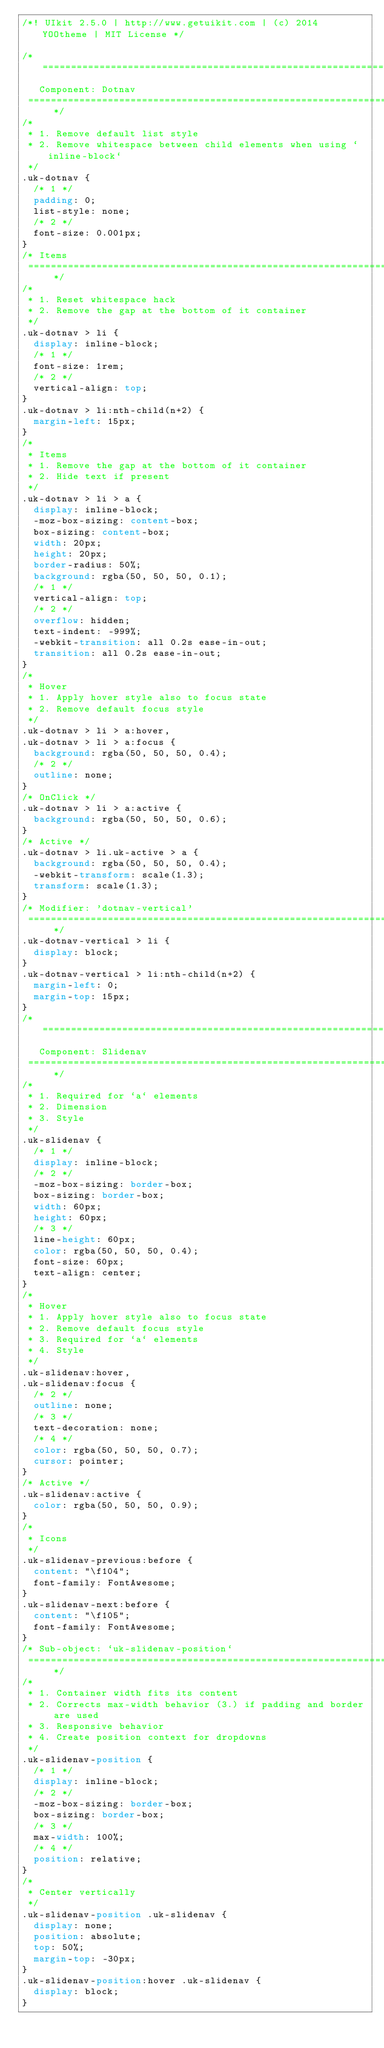<code> <loc_0><loc_0><loc_500><loc_500><_CSS_>/*! UIkit 2.5.0 | http://www.getuikit.com | (c) 2014 YOOtheme | MIT License */

/* ========================================================================
   Component: Dotnav
 ========================================================================== */
/*
 * 1. Remove default list style
 * 2. Remove whitespace between child elements when using `inline-block`
 */
.uk-dotnav {
  /* 1 */
  padding: 0;
  list-style: none;
  /* 2 */
  font-size: 0.001px;
}
/* Items
 ========================================================================== */
/*
 * 1. Reset whitespace hack
 * 2. Remove the gap at the bottom of it container
 */
.uk-dotnav > li {
  display: inline-block;
  /* 1 */
  font-size: 1rem;
  /* 2 */
  vertical-align: top;
}
.uk-dotnav > li:nth-child(n+2) {
  margin-left: 15px;
}
/*
 * Items
 * 1. Remove the gap at the bottom of it container
 * 2. Hide text if present
 */
.uk-dotnav > li > a {
  display: inline-block;
  -moz-box-sizing: content-box;
  box-sizing: content-box;
  width: 20px;
  height: 20px;
  border-radius: 50%;
  background: rgba(50, 50, 50, 0.1);
  /* 1 */
  vertical-align: top;
  /* 2 */
  overflow: hidden;
  text-indent: -999%;
  -webkit-transition: all 0.2s ease-in-out;
  transition: all 0.2s ease-in-out;
}
/*
 * Hover
 * 1. Apply hover style also to focus state
 * 2. Remove default focus style
 */
.uk-dotnav > li > a:hover,
.uk-dotnav > li > a:focus {
  background: rgba(50, 50, 50, 0.4);
  /* 2 */
  outline: none;
}
/* OnClick */
.uk-dotnav > li > a:active {
  background: rgba(50, 50, 50, 0.6);
}
/* Active */
.uk-dotnav > li.uk-active > a {
  background: rgba(50, 50, 50, 0.4);
  -webkit-transform: scale(1.3);
  transform: scale(1.3);
}
/* Modifier: 'dotnav-vertical'
 ========================================================================== */
.uk-dotnav-vertical > li {
  display: block;
}
.uk-dotnav-vertical > li:nth-child(n+2) {
  margin-left: 0;
  margin-top: 15px;
}
/* ========================================================================
   Component: Slidenav
 ========================================================================== */
/*
 * 1. Required for `a` elements
 * 2. Dimension
 * 3. Style
 */
.uk-slidenav {
  /* 1 */
  display: inline-block;
  /* 2 */
  -moz-box-sizing: border-box;
  box-sizing: border-box;
  width: 60px;
  height: 60px;
  /* 3 */
  line-height: 60px;
  color: rgba(50, 50, 50, 0.4);
  font-size: 60px;
  text-align: center;
}
/*
 * Hover
 * 1. Apply hover style also to focus state
 * 2. Remove default focus style
 * 3. Required for `a` elements
 * 4. Style
 */
.uk-slidenav:hover,
.uk-slidenav:focus {
  /* 2 */
  outline: none;
  /* 3 */
  text-decoration: none;
  /* 4 */
  color: rgba(50, 50, 50, 0.7);
  cursor: pointer;
}
/* Active */
.uk-slidenav:active {
  color: rgba(50, 50, 50, 0.9);
}
/*
 * Icons
 */
.uk-slidenav-previous:before {
  content: "\f104";
  font-family: FontAwesome;
}
.uk-slidenav-next:before {
  content: "\f105";
  font-family: FontAwesome;
}
/* Sub-object: `uk-slidenav-position`
 ========================================================================== */
/*
 * 1. Container width fits its content
 * 2. Corrects max-width behavior (3.) if padding and border are used
 * 3. Responsive behavior
 * 4. Create position context for dropdowns
 */
.uk-slidenav-position {
  /* 1 */
  display: inline-block;
  /* 2 */
  -moz-box-sizing: border-box;
  box-sizing: border-box;
  /* 3 */
  max-width: 100%;
  /* 4 */
  position: relative;
}
/*
 * Center vertically
 */
.uk-slidenav-position .uk-slidenav {
  display: none;
  position: absolute;
  top: 50%;
  margin-top: -30px;
}
.uk-slidenav-position:hover .uk-slidenav {
  display: block;
}</code> 